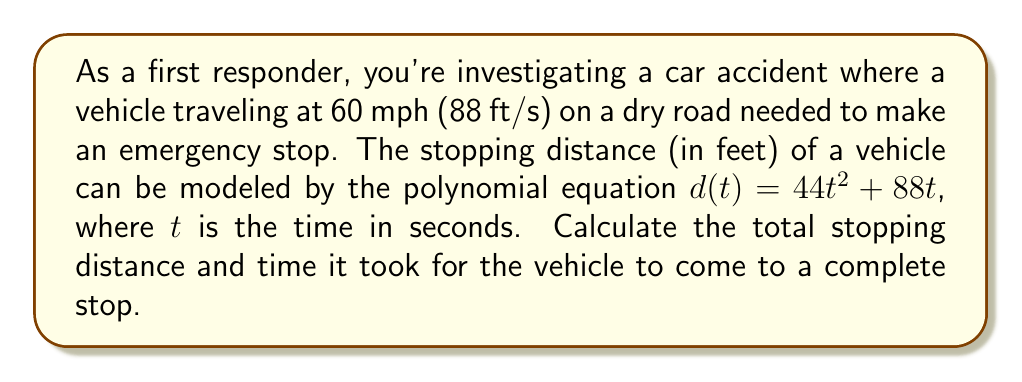Help me with this question. Let's approach this step-by-step:

1) The stopping distance is given by the polynomial $d(t) = 44t^2 + 88t$

2) To find when the vehicle comes to a complete stop, we need to find the velocity function by differentiating $d(t)$:

   $v(t) = \frac{d}{dt}(d(t)) = 88t + 88$

3) The vehicle stops when $v(t) = 0$:

   $88t + 88 = 0$
   $88t = -88$
   $t = -1$

4) Since time can't be negative, we use the positive root:
   $t = 1$ second

5) Now we can calculate the stopping distance by plugging $t = 1$ into $d(t)$:

   $d(1) = 44(1)^2 + 88(1) = 44 + 88 = 132$ feet

Therefore, it took 1 second for the vehicle to stop, and the total stopping distance was 132 feet.
Answer: 132 feet in 1 second 